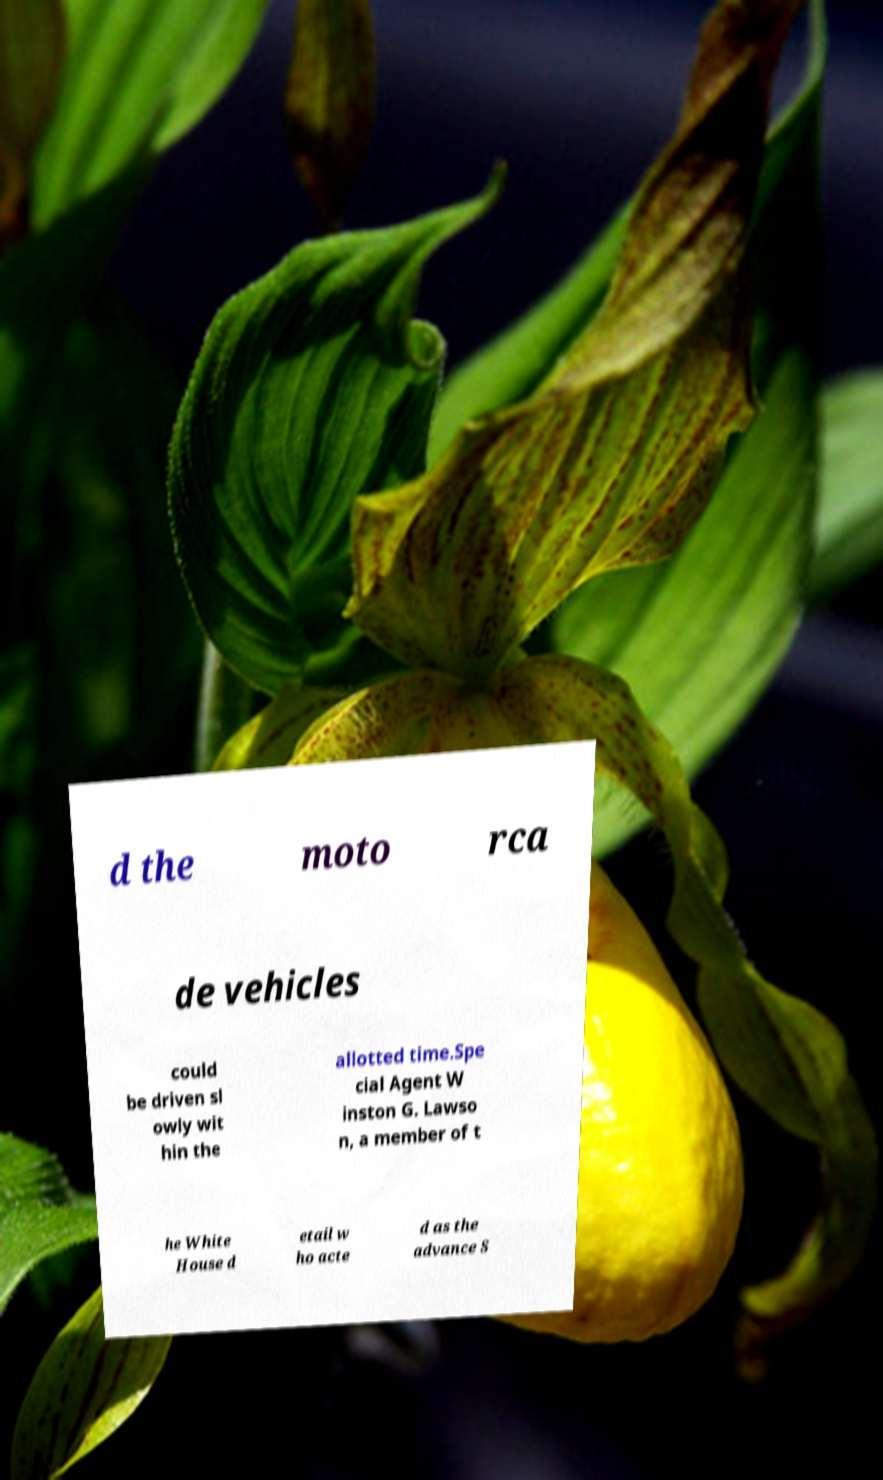Can you accurately transcribe the text from the provided image for me? d the moto rca de vehicles could be driven sl owly wit hin the allotted time.Spe cial Agent W inston G. Lawso n, a member of t he White House d etail w ho acte d as the advance S 